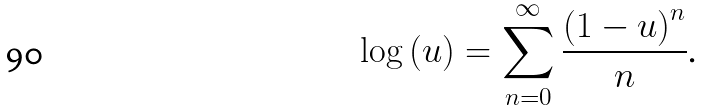<formula> <loc_0><loc_0><loc_500><loc_500>\log \left ( u \right ) = \sum _ { n = 0 } ^ { \infty } \frac { \left ( 1 - u \right ) ^ { n } } { n } \text {.}</formula> 